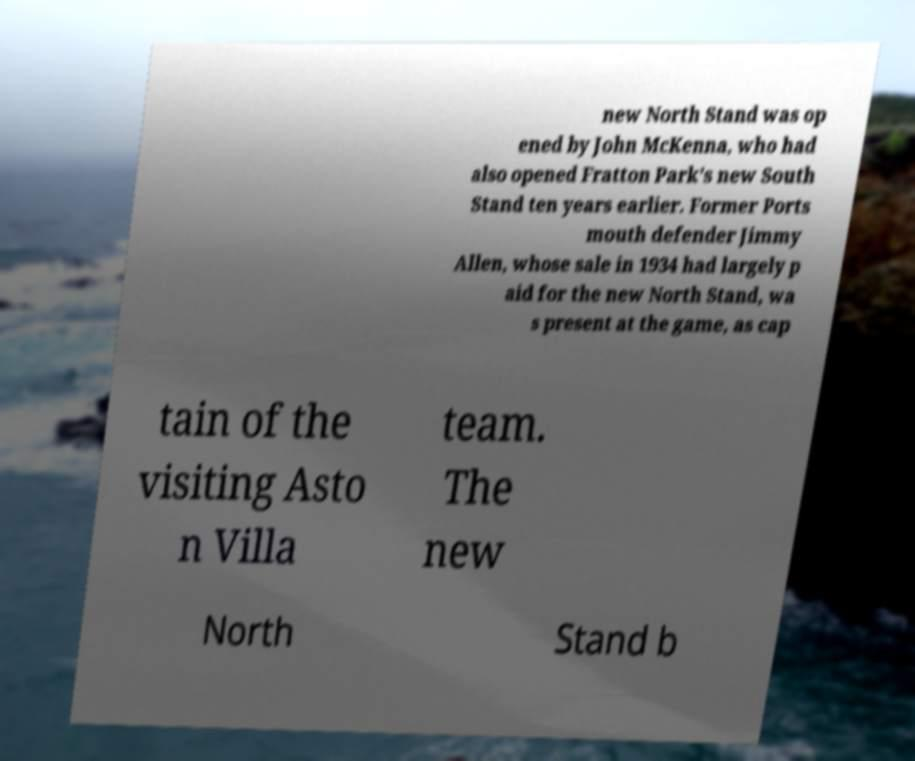Could you extract and type out the text from this image? new North Stand was op ened by John McKenna, who had also opened Fratton Park's new South Stand ten years earlier. Former Ports mouth defender Jimmy Allen, whose sale in 1934 had largely p aid for the new North Stand, wa s present at the game, as cap tain of the visiting Asto n Villa team. The new North Stand b 